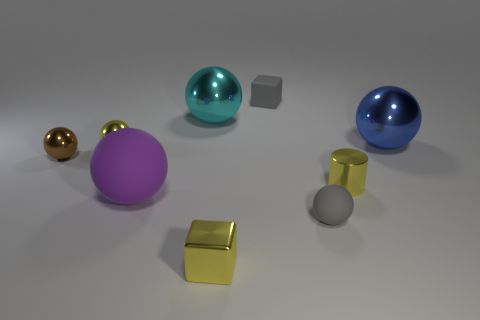Is there a tiny brown shiny object of the same shape as the big rubber thing?
Your answer should be compact. Yes. There is a yellow shiny object in front of the metallic cylinder; is its size the same as the rubber block?
Offer a very short reply. Yes. Is there a large purple matte thing?
Provide a succinct answer. Yes. What number of objects are shiny spheres that are left of the big cyan metal sphere or gray rubber objects?
Give a very brief answer. 4. Does the cylinder have the same color as the small block that is in front of the big cyan shiny ball?
Your answer should be compact. Yes. Is there a gray matte object that has the same size as the gray cube?
Provide a short and direct response. Yes. There is a tiny gray thing that is behind the large object that is in front of the tiny brown thing; what is it made of?
Your answer should be very brief. Rubber. What number of small objects are the same color as the tiny rubber block?
Give a very brief answer. 1. There is a large cyan thing that is made of the same material as the yellow cylinder; what is its shape?
Your answer should be compact. Sphere. What is the size of the matte thing that is left of the tiny yellow block?
Ensure brevity in your answer.  Large. 